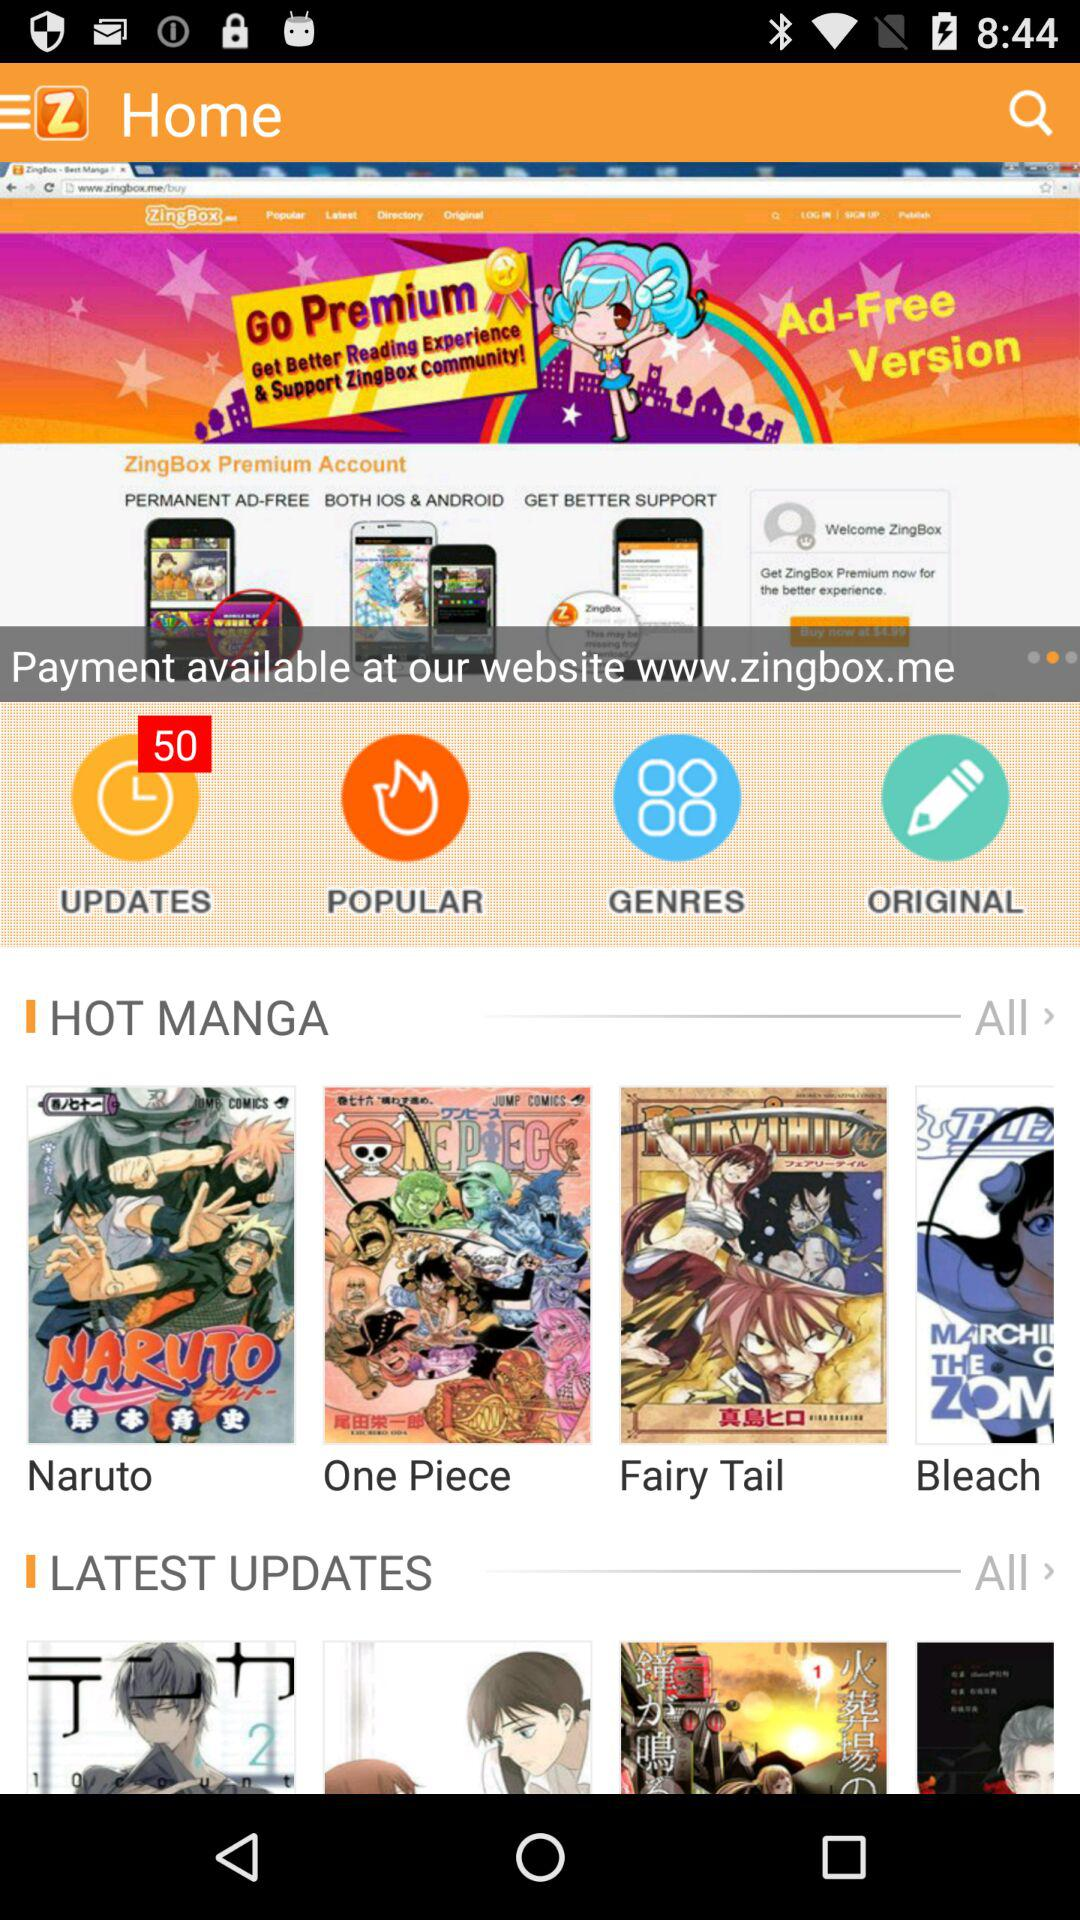How many notifications are there on "UPDATES"? There are 50 notifications. 